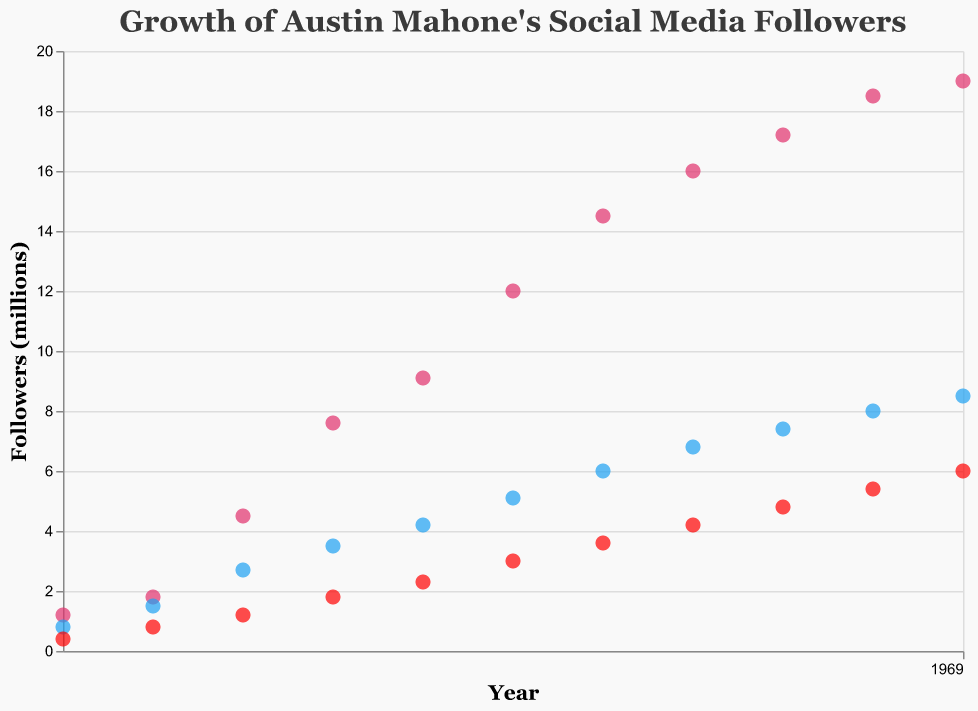what is the title of the scatter plot? The title is typically located at the top of the plot and provides a summary of the data being shown. The title in this scatter plot is "Growth of Austin Mahone's Social Media Followers".
Answer: Growth of Austin Mahone's Social Media Followers how many social media platforms are tracked in the scatter plot? The scatter plot contains three different colored points, each representing a different social media platform. These platforms are Instagram, Twitter, and YouTube.
Answer: 3 what color represents Twitter followers in the scatter plot? By observing the legend or the color of the points, we can see that Twitter followers are represented by the color blue.
Answer: Blue how many Instagram followers did Austin Mahone have in 2018? By finding the year 2018 on the x-axis and following it up to the Instagram series (which is colored pink), we see he had 12 million Instagram followers.
Answer: 12 million which year saw the largest increase in YouTube subscribers for Austin Mahone? By examining the series of red points representing YouTube subscribers, the largest increase appears between 2017 and 2018, where it jumps from 2.3 million to 3.0 million.
Answer: 2017-2018 compare the growth rate of Instagram followers between 2016 and 2017 to the growth rate between 2018 and 2019. which is larger? From 2016 to 2017, Instagram followers grew from 7.6 million to 9.1 million, a 1.5 million increase. From 2018 to 2019, it grew from 12.0 million to 14.5 million, a 2.5 million increase. The growth rate is larger between 2018 and 2019.
Answer: 2018-2019 what is the average number of Twitter followers in 2020 and 2021? Finding the values for Twitter followers in 2020 and 2021, which are 6.8 and 7.4 million respectively, we calculate the average as (6.8 + 7.4) / 2 = 7.1 million.
Answer: 7.1 million in which year did Austin Mahone reach 5 million YouTube subscribers? By following the red series of points for YouTube subscribers, we see that Austin Mahone reached 5 million in the year 2022.
Answer: 2022 how many total data points are in the scatter plot? Each year from 2013 to 2023 has one data point per platform, resulting in 11 years x 3 platforms = 33 data points.
Answer: 33 